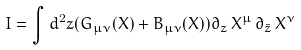Convert formula to latex. <formula><loc_0><loc_0><loc_500><loc_500>I = \int d ^ { 2 } z ( G _ { \mu \nu } ( X ) + B _ { \mu \nu } ( X ) ) \partial _ { z } \, X ^ { \mu } \, \partial _ { \bar { z } } \, X ^ { \nu }</formula> 